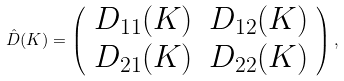Convert formula to latex. <formula><loc_0><loc_0><loc_500><loc_500>\hat { D } ( K ) = \left ( \begin{array} { l l } D _ { 1 1 } ( K ) & D _ { 1 2 } ( K ) \\ D _ { 2 1 } ( K ) & D _ { 2 2 } ( K ) \\ \end{array} \right ) ,</formula> 